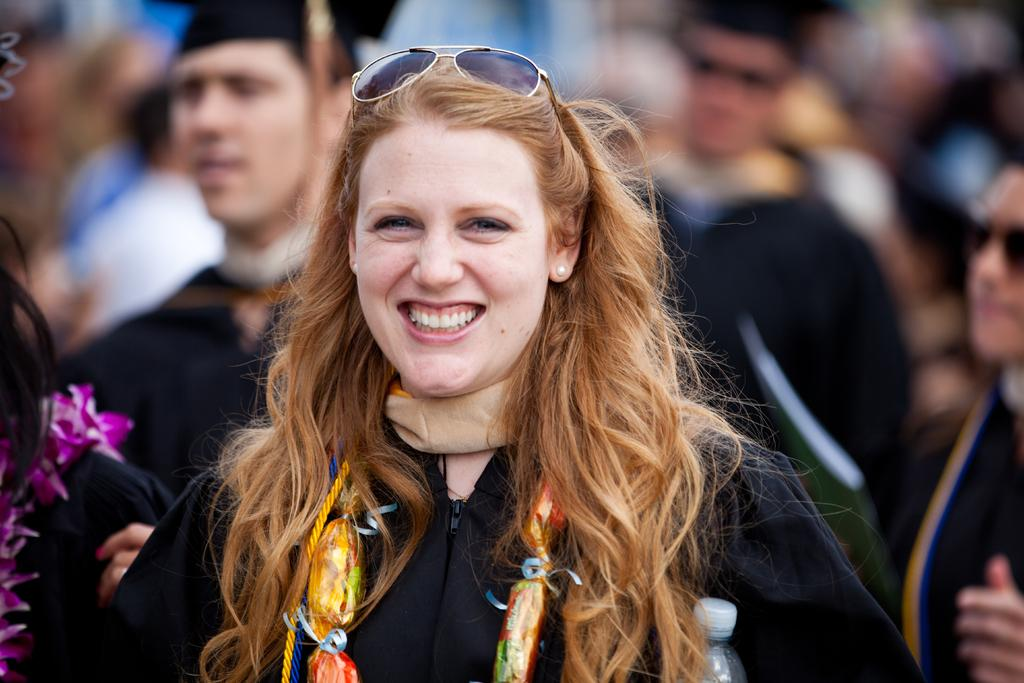Who is the main subject in the image? There is a woman in the image. What is the woman wearing? The woman is wearing a black dress. What expression does the woman have? The woman is smiling. Can you describe the other persons in the image? The other persons are wearing graduation dress. Is there a cobweb visible in the image? There is no mention of a cobweb in the provided facts, so it cannot be determined if one is present in the image. 